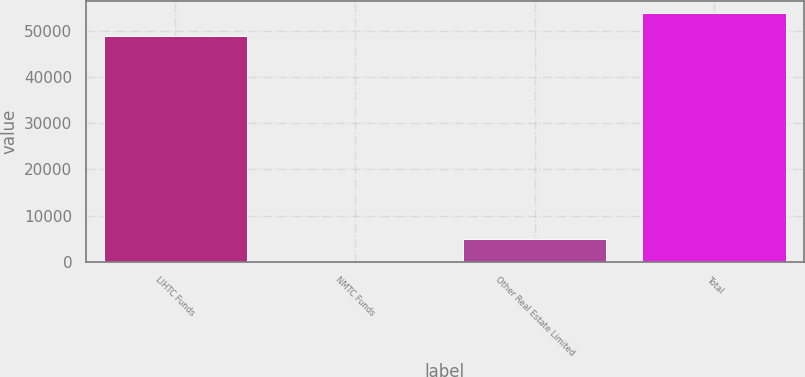Convert chart. <chart><loc_0><loc_0><loc_500><loc_500><bar_chart><fcel>LIHTC Funds<fcel>NMTC Funds<fcel>Other Real Estate Limited<fcel>Total<nl><fcel>48915<fcel>13<fcel>4922.8<fcel>53824.8<nl></chart> 